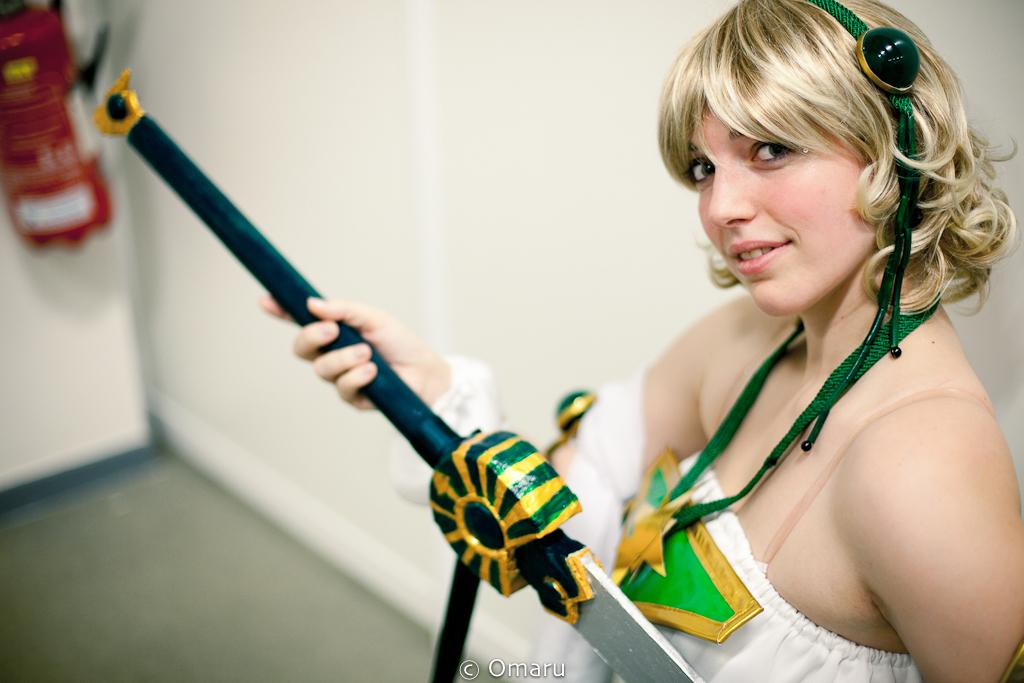What is the main subject of the image? There is a person in the image. What is the person wearing? The person is wearing a white dress. What is the person holding in the image? The person is holding something. What can be seen in the background of the image? There is a white wall and a red color object in the background of the image. What is the name of the person in the image? The provided facts do not mention the name of the person, so we cannot determine their name from the image. Was there an earthquake during the time the image was taken? There is no information about an earthquake or any other events in the image or the provided facts, so we cannot determine if there was an earthquake during the time the image was taken. 